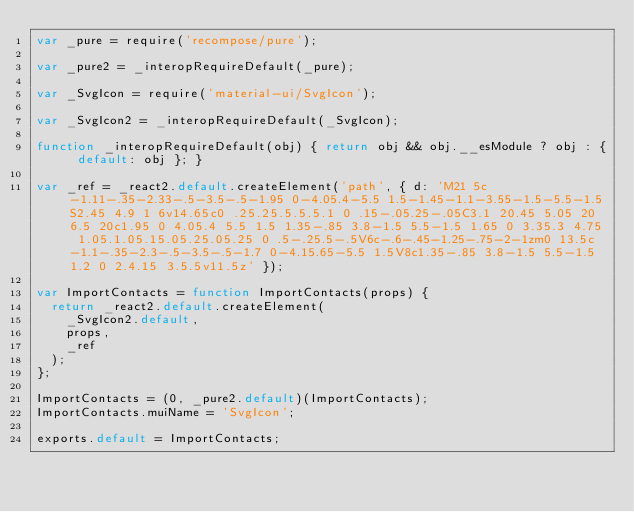Convert code to text. <code><loc_0><loc_0><loc_500><loc_500><_JavaScript_>var _pure = require('recompose/pure');

var _pure2 = _interopRequireDefault(_pure);

var _SvgIcon = require('material-ui/SvgIcon');

var _SvgIcon2 = _interopRequireDefault(_SvgIcon);

function _interopRequireDefault(obj) { return obj && obj.__esModule ? obj : { default: obj }; }

var _ref = _react2.default.createElement('path', { d: 'M21 5c-1.11-.35-2.33-.5-3.5-.5-1.95 0-4.05.4-5.5 1.5-1.45-1.1-3.55-1.5-5.5-1.5S2.45 4.9 1 6v14.65c0 .25.25.5.5.5.1 0 .15-.05.25-.05C3.1 20.45 5.05 20 6.5 20c1.95 0 4.05.4 5.5 1.5 1.35-.85 3.8-1.5 5.5-1.5 1.65 0 3.35.3 4.75 1.05.1.05.15.05.25.05.25 0 .5-.25.5-.5V6c-.6-.45-1.25-.75-2-1zm0 13.5c-1.1-.35-2.3-.5-3.5-.5-1.7 0-4.15.65-5.5 1.5V8c1.35-.85 3.8-1.5 5.5-1.5 1.2 0 2.4.15 3.5.5v11.5z' });

var ImportContacts = function ImportContacts(props) {
  return _react2.default.createElement(
    _SvgIcon2.default,
    props,
    _ref
  );
};

ImportContacts = (0, _pure2.default)(ImportContacts);
ImportContacts.muiName = 'SvgIcon';

exports.default = ImportContacts;</code> 